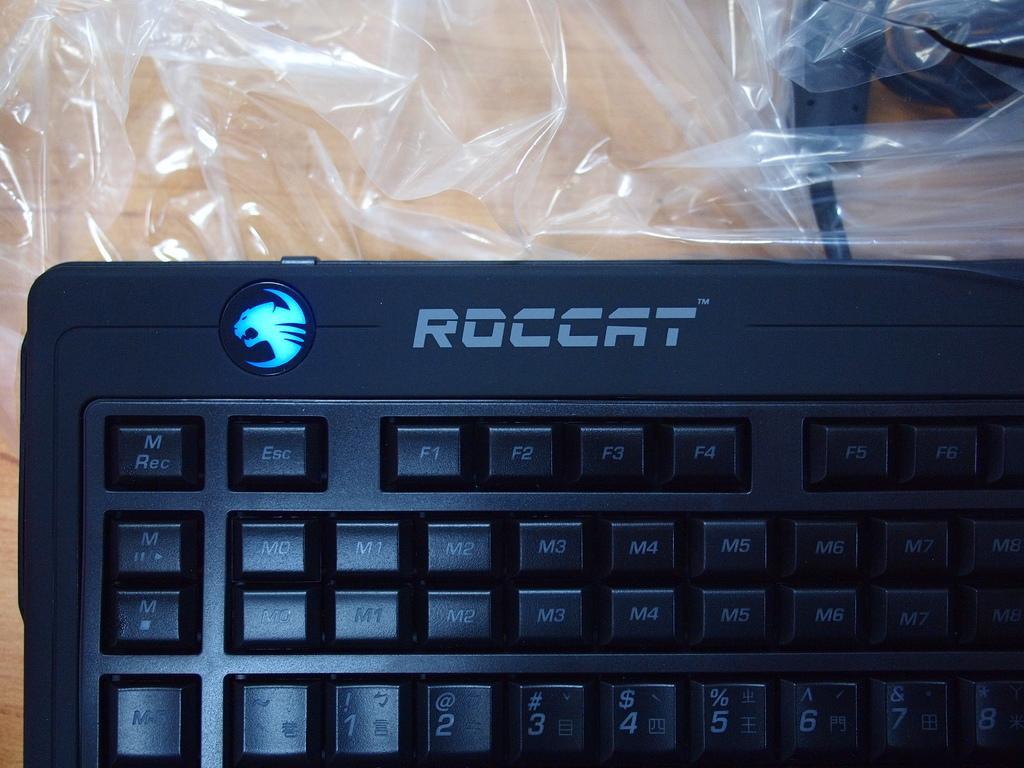Can you describe this image briefly? On the bottom we can see a black color keyboard on the table. On the top we can see cables and plastic cover. 